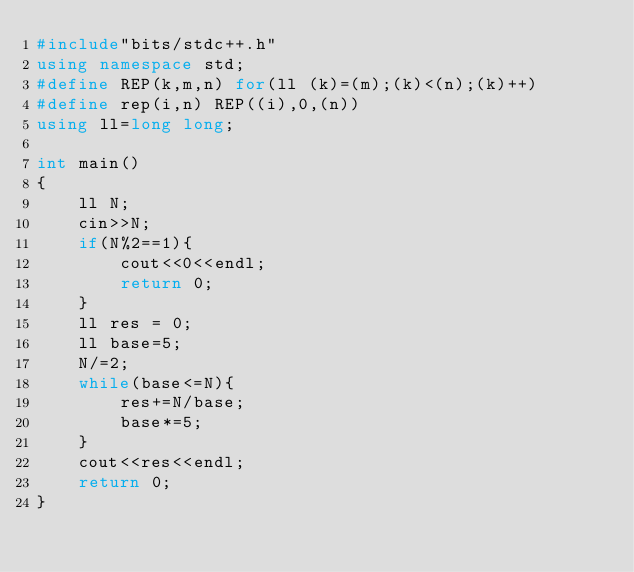<code> <loc_0><loc_0><loc_500><loc_500><_C++_>#include"bits/stdc++.h"
using namespace std;
#define REP(k,m,n) for(ll (k)=(m);(k)<(n);(k)++)
#define rep(i,n) REP((i),0,(n))
using ll=long long;

int main()
{
	ll N;
	cin>>N;
	if(N%2==1){
		cout<<0<<endl;
		return 0;
	}
	ll res = 0;
	ll base=5;
	N/=2;
	while(base<=N){
		res+=N/base;
		base*=5;
	}
	cout<<res<<endl;
	return 0;
}
</code> 